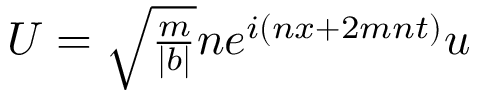<formula> <loc_0><loc_0><loc_500><loc_500>\begin{array} { r } { U = \sqrt { \frac { m } { | b | } } n e ^ { i ( n x + 2 m n t ) } u } \end{array}</formula> 